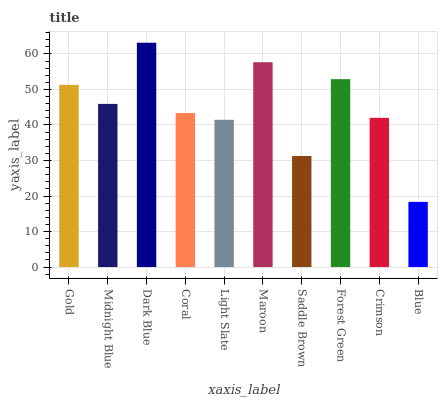Is Midnight Blue the minimum?
Answer yes or no. No. Is Midnight Blue the maximum?
Answer yes or no. No. Is Gold greater than Midnight Blue?
Answer yes or no. Yes. Is Midnight Blue less than Gold?
Answer yes or no. Yes. Is Midnight Blue greater than Gold?
Answer yes or no. No. Is Gold less than Midnight Blue?
Answer yes or no. No. Is Midnight Blue the high median?
Answer yes or no. Yes. Is Coral the low median?
Answer yes or no. Yes. Is Dark Blue the high median?
Answer yes or no. No. Is Light Slate the low median?
Answer yes or no. No. 